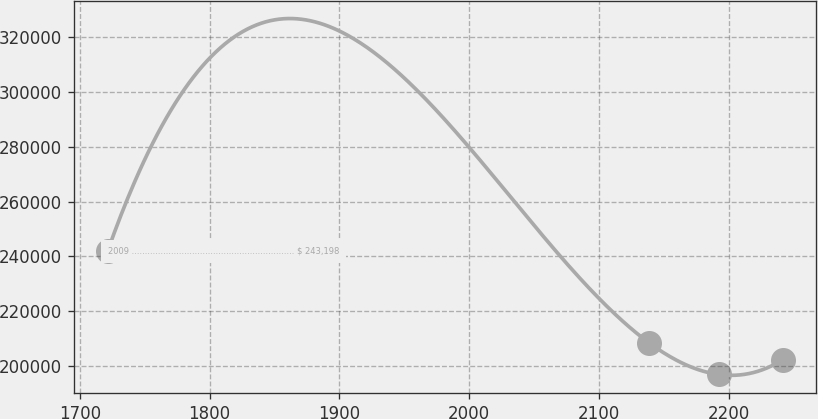<chart> <loc_0><loc_0><loc_500><loc_500><line_chart><ecel><fcel>2009 .............................................................. $ 243,198<nl><fcel>1721.33<fcel>241815<nl><fcel>2138.84<fcel>208413<nl><fcel>2192.32<fcel>196899<nl><fcel>2241.7<fcel>202289<nl></chart> 